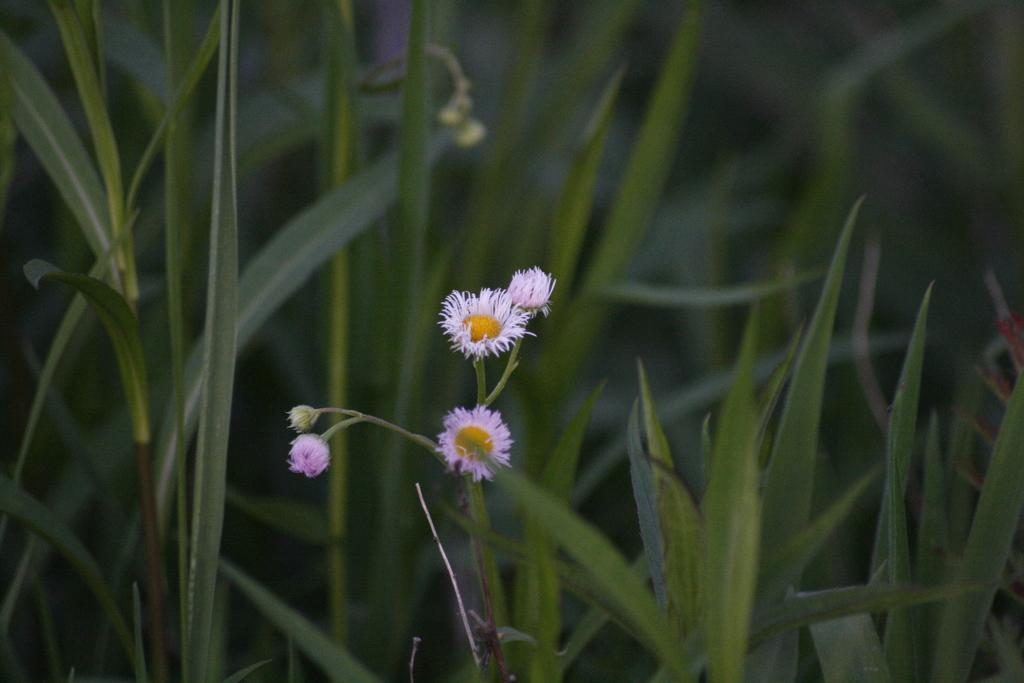What type of plants are in the image? There are flowers in the image. What part of the flowers can be seen in the image? The flowers have stems in the image. What can be seen in the background of the image? There is grass visible in the background of the image. What type of bird is attending the meeting in the image? There is no bird or meeting present in the image; it features flowers and grass. How many children are playing with the flowers in the image? There are no children present in the image; it features flowers and grass. 